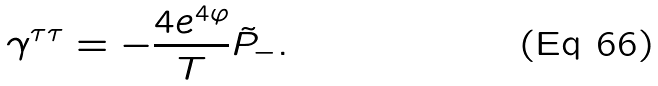<formula> <loc_0><loc_0><loc_500><loc_500>\gamma ^ { \tau \tau } = - \frac { 4 e ^ { 4 \varphi } } { T } \tilde { P } _ { - } .</formula> 